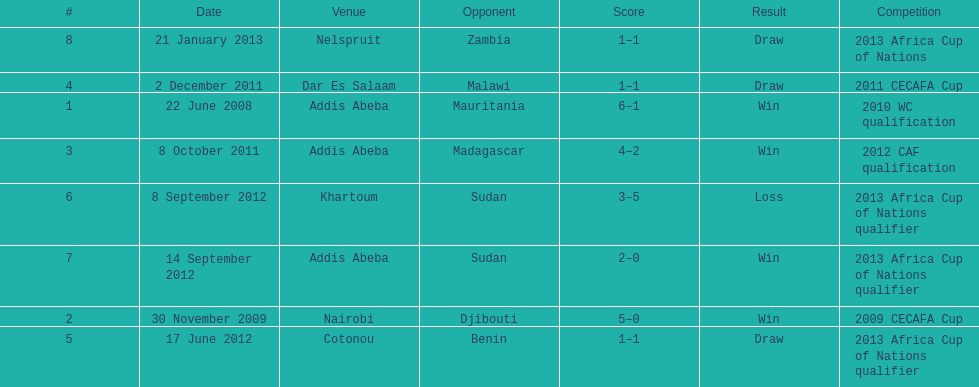True or false? in comparison, the ethiopian national team has more draws than wins. False. 